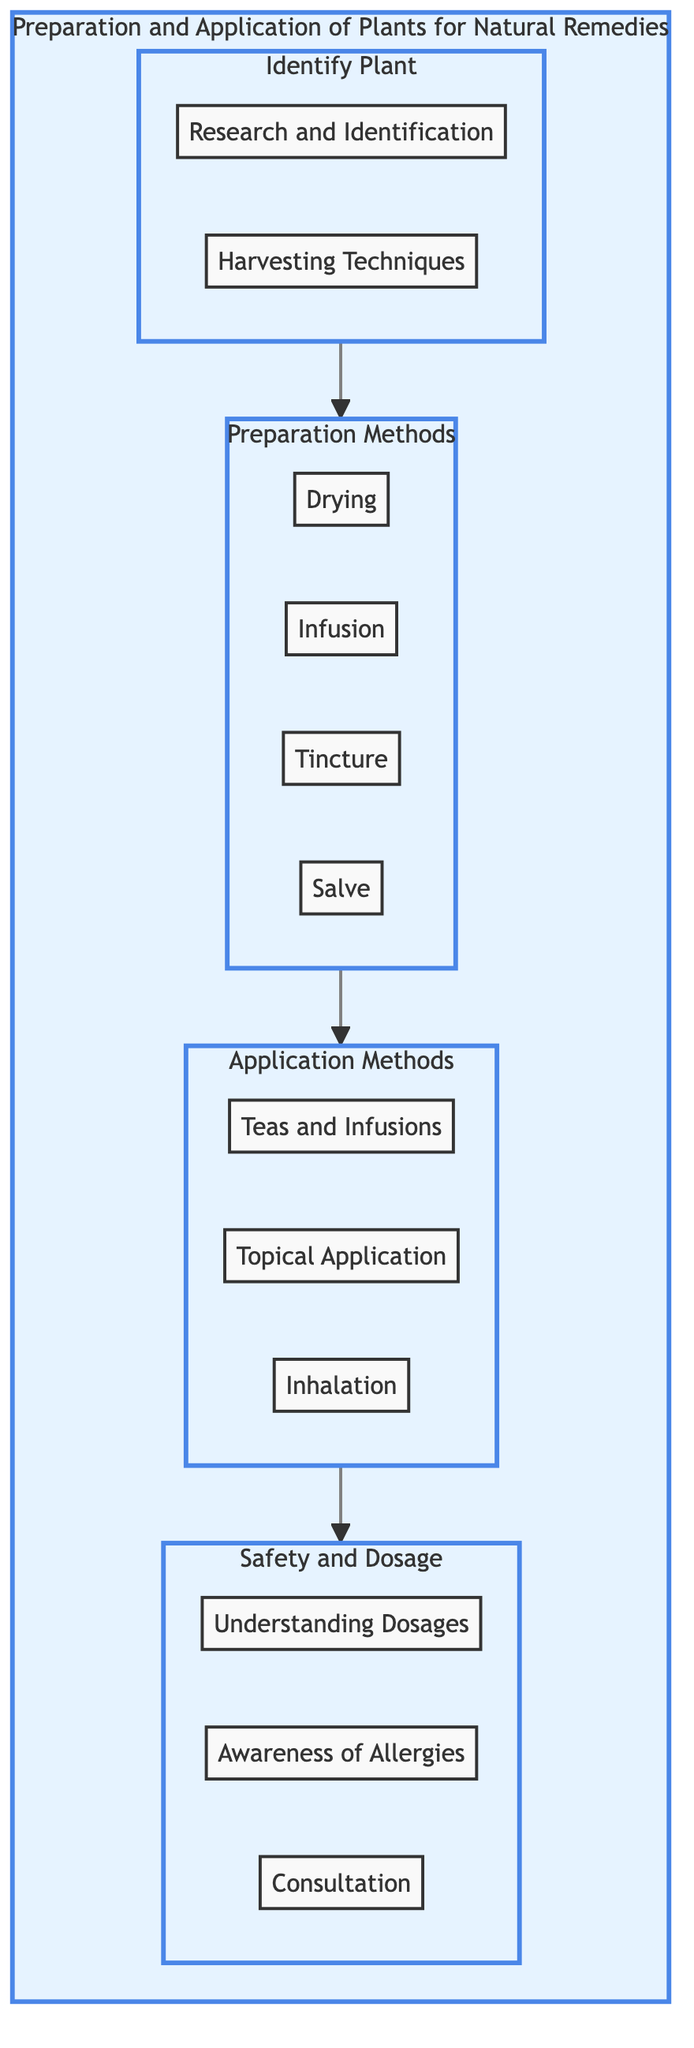What are the two elements under Identify Plant? The diagram shows two elements listed under the Identify Plant section: "Research and Identification" and "Harvesting Techniques".
Answer: Research and Identification, Harvesting Techniques How many preparation methods are listed in the diagram? The diagram enumerates four preparation methods, which are Drying, Infusion, Tincture, and Salve.
Answer: Four Which application method is associated with external use? The Topical Application method is specifically mentioned as being applied directly to the skin for localized treatment.
Answer: Topical Application What is the relationship between Preparation Methods and Application Methods? The diagram connects Preparation Methods to Application Methods through a direct arrow, indicating that the preparation processes lead into how the plants can be applied.
Answer: Direct connection What are the three elements listed under Safety and Dosage? The diagram identifies three important safety measures: "Understanding Dosages", "Awareness of Allergies", and "Consultation".
Answer: Understanding Dosages, Awareness of Allergies, Consultation Which preparation method extracts beneficial compounds using hot water? The Infusion method extracts beneficial compounds from the plant material by steeping it in hot water.
Answer: Infusion What do the elements in Safety and Dosage suggest about plant usage? They indicate that users should learn appropriate dosages, be aware of allergies, and consult healthcare providers for safe usage.
Answer: Caution and consultation How many application methods are shown in the diagram? The diagram lists three application methods: Teas and Infusions, Topical Application, and Inhalation.
Answer: Three Which element involves creating a concentrated liquid extract? The Tincture method involves soaking the plant in alcohol or vinegar for several weeks to create a concentrated liquid extract.
Answer: Tincture 